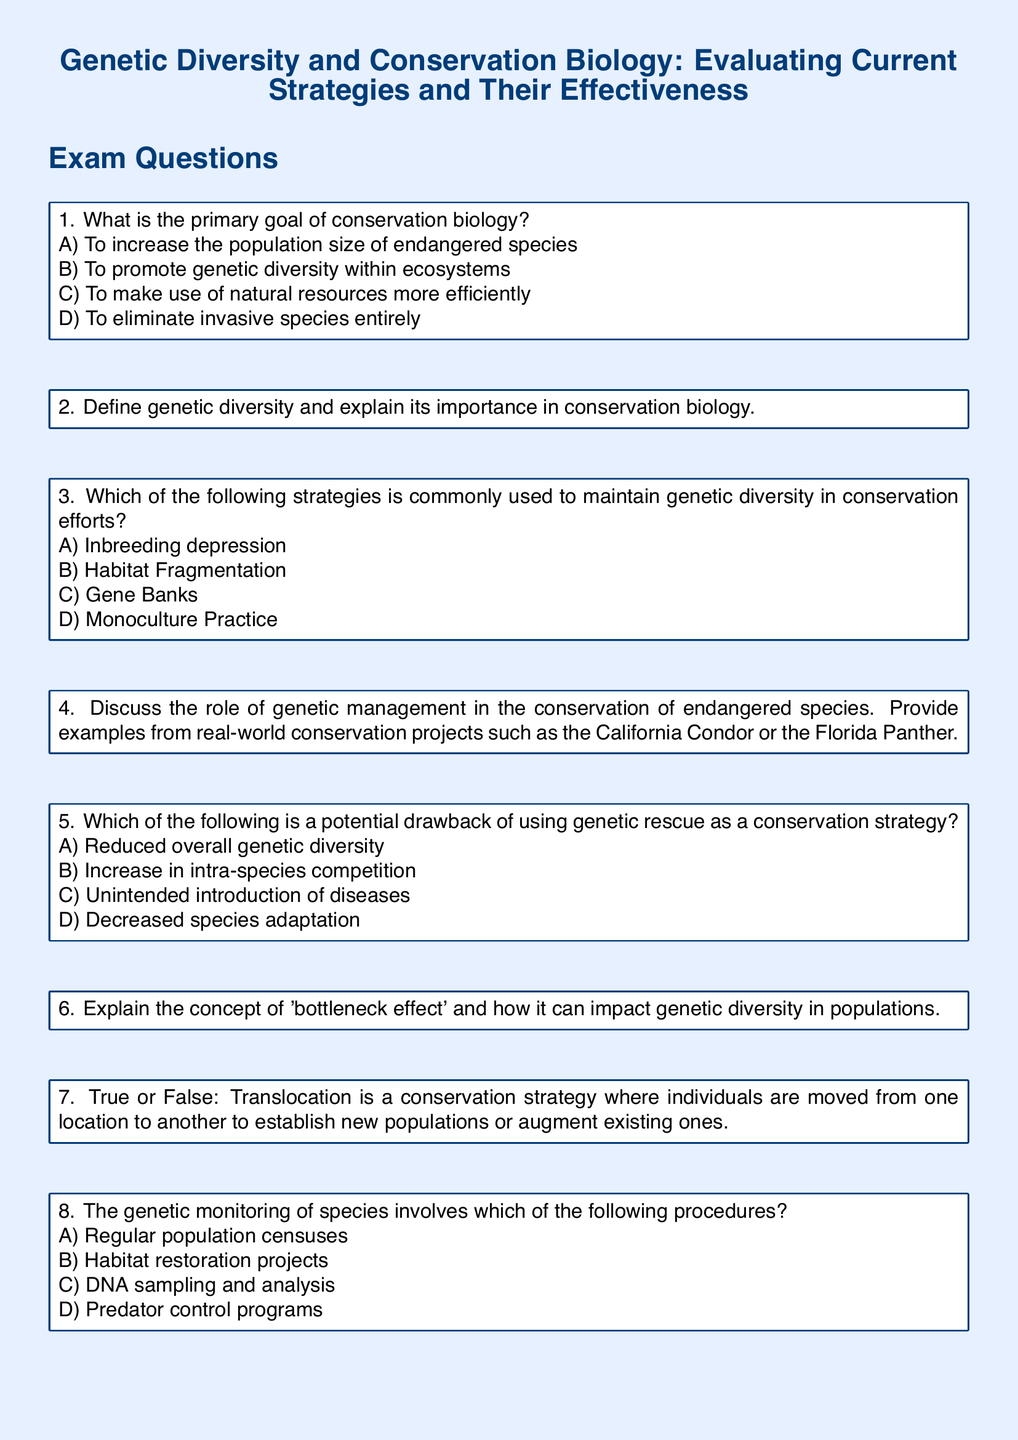What is the primary goal of conservation biology? The primary goal of conservation biology can be found in question 1 of the exam, which outlines various options, with one being to promote genetic diversity within ecosystems.
Answer: To promote genetic diversity within ecosystems Define genetic diversity The answer to this is found in question 2, where it asks for an explanation about genetic diversity and its importance.
Answer: N/A Which strategy is commonly used to maintain genetic diversity? Question 3 lists options for strategies, with one being Gene Banks as a method commonly used in conservation efforts.
Answer: Gene Banks What is the bottleneck effect? The explanation of the bottleneck effect and its impact on genetic diversity can be derived from question 6, which asks for a definition and its implications.
Answer: N/A What is the potential drawback of using genetic rescue? In question 5, the options include potential drawbacks related to genetic rescue, with unintended introduction of diseases being one of them.
Answer: Unintended introduction of diseases What does translocation mean in conservation strategies? Question 7 states a true or false statement regarding translocation, indicating it involves moving individuals to establish or augment populations.
Answer: True What involves genetic monitoring of species? Question 8 includes a list of procedures for genetic monitoring, from which DNA sampling and analysis is one option listed.
Answer: DNA sampling and analysis Which species is mentioned in the context of genetic management? Question 4 refers to specific examples including the California Condor and the Florida Panther in the context of genetic management.
Answer: California Condor or Florida Panther 